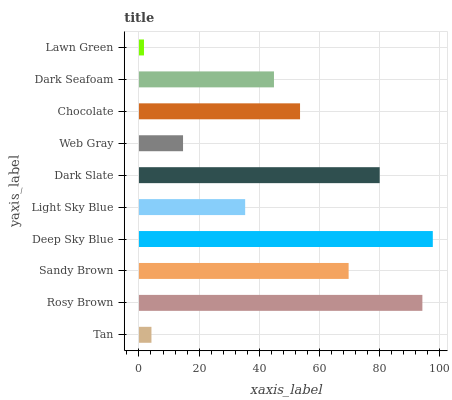Is Lawn Green the minimum?
Answer yes or no. Yes. Is Deep Sky Blue the maximum?
Answer yes or no. Yes. Is Rosy Brown the minimum?
Answer yes or no. No. Is Rosy Brown the maximum?
Answer yes or no. No. Is Rosy Brown greater than Tan?
Answer yes or no. Yes. Is Tan less than Rosy Brown?
Answer yes or no. Yes. Is Tan greater than Rosy Brown?
Answer yes or no. No. Is Rosy Brown less than Tan?
Answer yes or no. No. Is Chocolate the high median?
Answer yes or no. Yes. Is Dark Seafoam the low median?
Answer yes or no. Yes. Is Light Sky Blue the high median?
Answer yes or no. No. Is Dark Slate the low median?
Answer yes or no. No. 